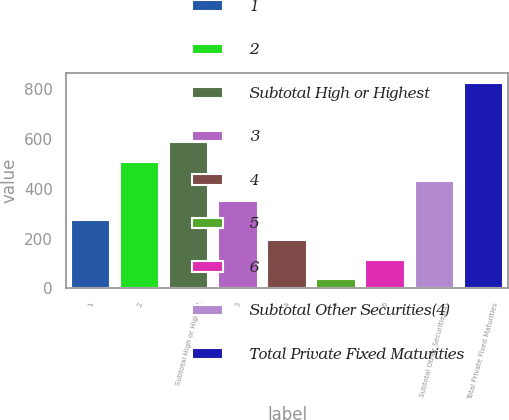Convert chart. <chart><loc_0><loc_0><loc_500><loc_500><bar_chart><fcel>1<fcel>2<fcel>Subtotal High or Highest<fcel>3<fcel>4<fcel>5<fcel>6<fcel>Subtotal Other Securities(4)<fcel>Total Private Fixed Maturities<nl><fcel>272.4<fcel>508.8<fcel>587.6<fcel>351.2<fcel>193.6<fcel>36<fcel>114.8<fcel>430<fcel>824<nl></chart> 